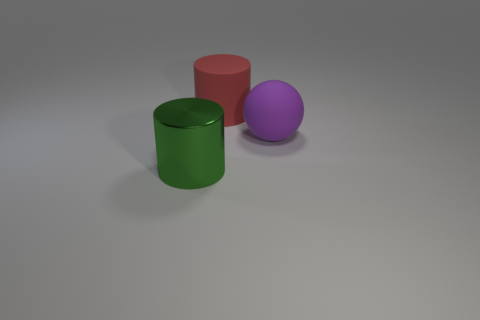There is another object that is the same shape as the red matte thing; what material is it?
Your answer should be compact. Metal. How many things are things that are in front of the big purple rubber thing or matte objects that are right of the rubber cylinder?
Make the answer very short. 2. There is a metal cylinder; is its color the same as the large cylinder behind the green cylinder?
Ensure brevity in your answer.  No. There is a large red object that is the same material as the purple ball; what is its shape?
Provide a succinct answer. Cylinder. What number of large matte spheres are there?
Your answer should be compact. 1. How many things are things to the left of the sphere or purple objects?
Offer a terse response. 3. There is a cylinder in front of the big purple rubber object; does it have the same color as the sphere?
Provide a short and direct response. No. How many small objects are cylinders or purple rubber balls?
Make the answer very short. 0. Is the number of green metallic cylinders greater than the number of small cylinders?
Offer a very short reply. Yes. Are the large purple ball and the green object made of the same material?
Ensure brevity in your answer.  No. 